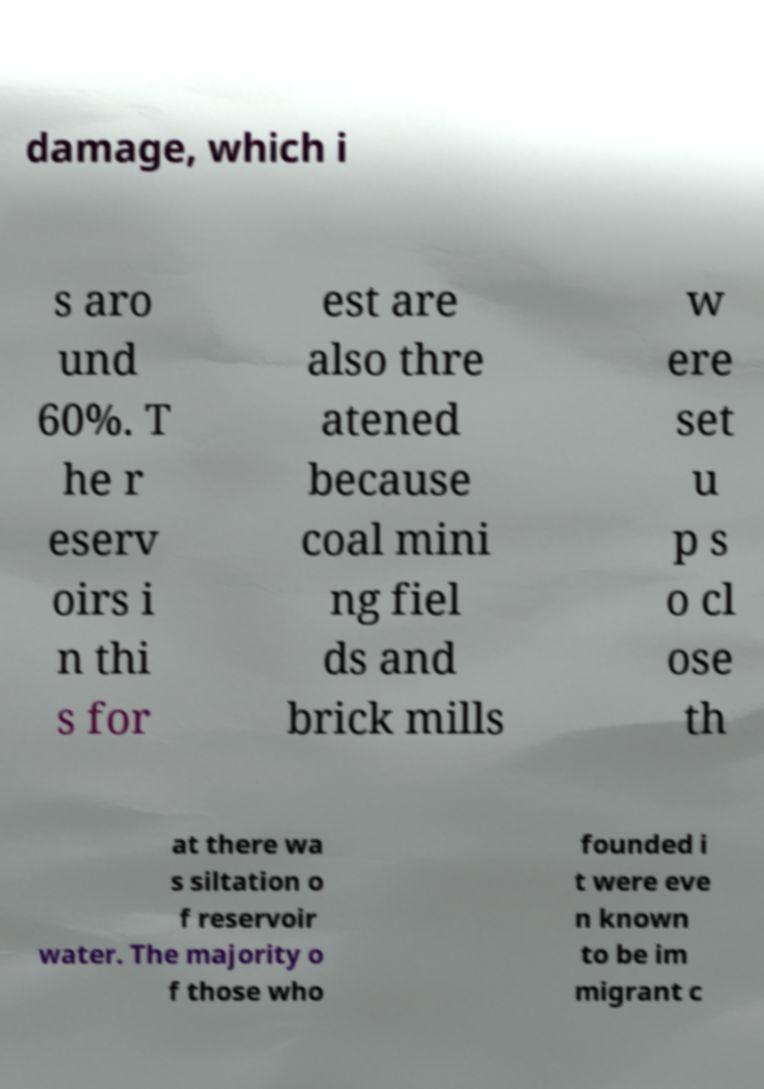There's text embedded in this image that I need extracted. Can you transcribe it verbatim? damage, which i s aro und 60%. T he r eserv oirs i n thi s for est are also thre atened because coal mini ng fiel ds and brick mills w ere set u p s o cl ose th at there wa s siltation o f reservoir water. The majority o f those who founded i t were eve n known to be im migrant c 